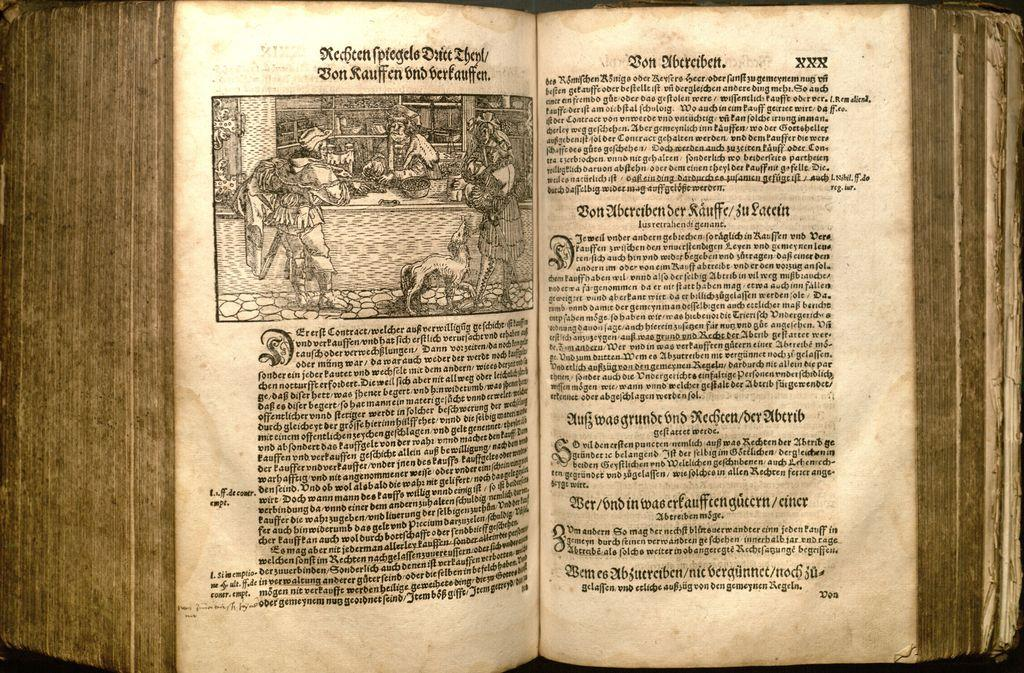<image>
Write a terse but informative summary of the picture. The very old book shown has the words Rechten fpiegels at the top. 